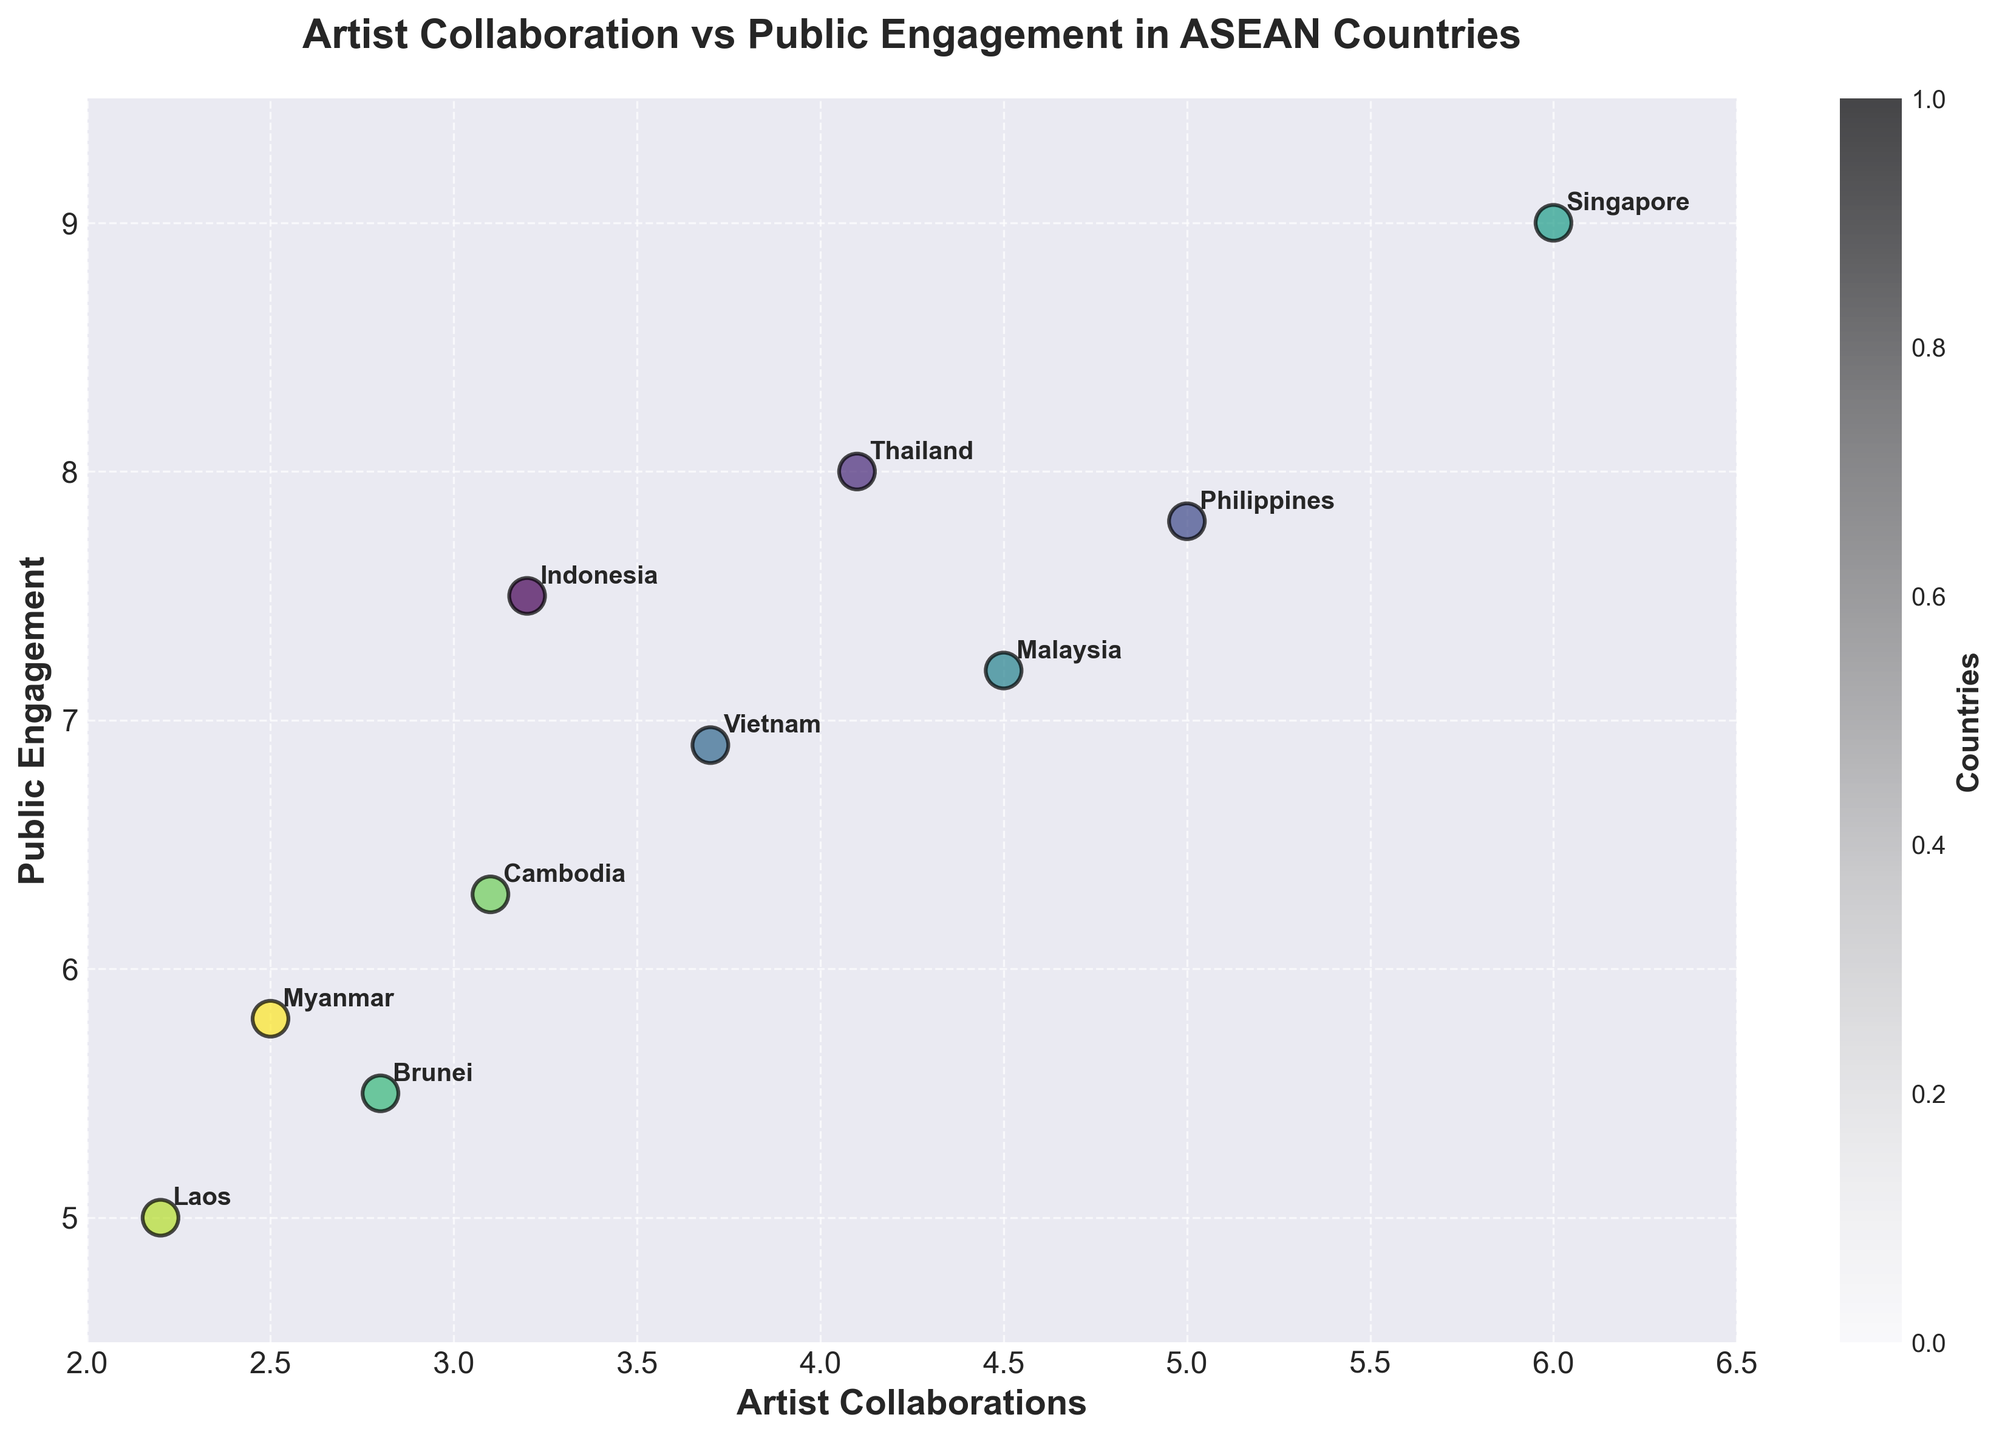What's the title of the figure? The title is displayed at the top of the figure.
Answer: Artist Collaboration vs Public Engagement in ASEAN Countries How many countries are represented in the scatter plot? Count the number of data points or country labels annotated in the figure.
Answer: 10 Which country has the highest public engagement level? Look for the country with the highest y-value (public engagement level) on the scatter plot.
Answer: Singapore Which country has the lowest artist collaboration rate? Identify the country with the smallest x-value (artist collaboration rate) on the scatter plot.
Answer: Laos What is the public engagement level for Malaysia? Locate the data point labeled "Malaysia" and find its y-coordinate (public engagement level).
Answer: 7.2 What is the average artist collaboration rate for the countries shown? Sum the artist collaboration rates of all countries and divide by the number of countries: (3.2 + 4.1 + 5.0 + 3.7 + 4.5 + 6.0 + 2.8 + 3.1 + 2.2 + 2.5)/10
Answer: 3.71 Which country has a higher artist collaboration rate, Thailand or Philippines? Compare the x-values (artist collaboration rates) of Thailand and Philippines on the scatter plot.
Answer: Philippines What's the difference in public engagement levels between Brunei and Cambodia? Subtract the public engagement level of Cambodia from that of Brunei: 5.5 - 6.3
Answer: -0.8 How are public engagement levels generally related to artist collaboration rates in the ASEAN countries? Observe the trend of the data points on the scatter plot to understand the relationship between the x-values (artist collaboration rates) and y-values (public engagement levels).
Answer: Higher artist collaboration rates generally correlate with higher public engagement levels What is the color scheme used in the scatter plot? The scatter plot uses a gradient color scheme to differentiate countries. This gradient is likely based on a color map like 'viridis'.
Answer: Gradient-based on 'viridis' color map 